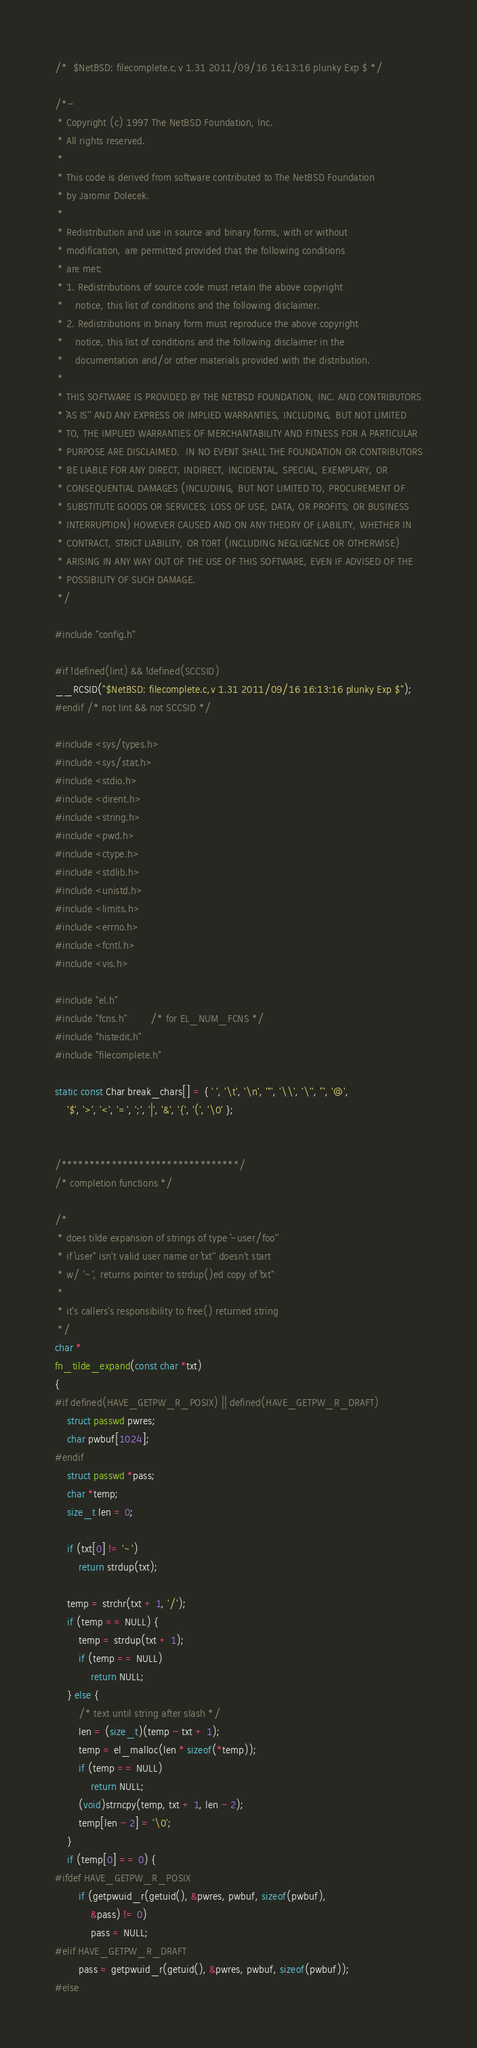<code> <loc_0><loc_0><loc_500><loc_500><_C_>/*	$NetBSD: filecomplete.c,v 1.31 2011/09/16 16:13:16 plunky Exp $	*/

/*-
 * Copyright (c) 1997 The NetBSD Foundation, Inc.
 * All rights reserved.
 *
 * This code is derived from software contributed to The NetBSD Foundation
 * by Jaromir Dolecek.
 *
 * Redistribution and use in source and binary forms, with or without
 * modification, are permitted provided that the following conditions
 * are met:
 * 1. Redistributions of source code must retain the above copyright
 *    notice, this list of conditions and the following disclaimer.
 * 2. Redistributions in binary form must reproduce the above copyright
 *    notice, this list of conditions and the following disclaimer in the
 *    documentation and/or other materials provided with the distribution.
 *
 * THIS SOFTWARE IS PROVIDED BY THE NETBSD FOUNDATION, INC. AND CONTRIBUTORS
 * ``AS IS'' AND ANY EXPRESS OR IMPLIED WARRANTIES, INCLUDING, BUT NOT LIMITED
 * TO, THE IMPLIED WARRANTIES OF MERCHANTABILITY AND FITNESS FOR A PARTICULAR
 * PURPOSE ARE DISCLAIMED.  IN NO EVENT SHALL THE FOUNDATION OR CONTRIBUTORS
 * BE LIABLE FOR ANY DIRECT, INDIRECT, INCIDENTAL, SPECIAL, EXEMPLARY, OR
 * CONSEQUENTIAL DAMAGES (INCLUDING, BUT NOT LIMITED TO, PROCUREMENT OF
 * SUBSTITUTE GOODS OR SERVICES; LOSS OF USE, DATA, OR PROFITS; OR BUSINESS
 * INTERRUPTION) HOWEVER CAUSED AND ON ANY THEORY OF LIABILITY, WHETHER IN
 * CONTRACT, STRICT LIABILITY, OR TORT (INCLUDING NEGLIGENCE OR OTHERWISE)
 * ARISING IN ANY WAY OUT OF THE USE OF THIS SOFTWARE, EVEN IF ADVISED OF THE
 * POSSIBILITY OF SUCH DAMAGE.
 */

#include "config.h"

#if !defined(lint) && !defined(SCCSID)
__RCSID("$NetBSD: filecomplete.c,v 1.31 2011/09/16 16:13:16 plunky Exp $");
#endif /* not lint && not SCCSID */

#include <sys/types.h>
#include <sys/stat.h>
#include <stdio.h>
#include <dirent.h>
#include <string.h>
#include <pwd.h>
#include <ctype.h>
#include <stdlib.h>
#include <unistd.h>
#include <limits.h>
#include <errno.h>
#include <fcntl.h>
#include <vis.h>

#include "el.h"
#include "fcns.h"		/* for EL_NUM_FCNS */
#include "histedit.h"
#include "filecomplete.h"

static const Char break_chars[] = { ' ', '\t', '\n', '"', '\\', '\'', '`', '@',
    '$', '>', '<', '=', ';', '|', '&', '{', '(', '\0' };


/********************************/
/* completion functions */

/*
 * does tilde expansion of strings of type ``~user/foo''
 * if ``user'' isn't valid user name or ``txt'' doesn't start
 * w/ '~', returns pointer to strdup()ed copy of ``txt''
 *
 * it's callers's responsibility to free() returned string
 */
char *
fn_tilde_expand(const char *txt)
{
#if defined(HAVE_GETPW_R_POSIX) || defined(HAVE_GETPW_R_DRAFT)
	struct passwd pwres;
	char pwbuf[1024];
#endif
	struct passwd *pass;
	char *temp;
	size_t len = 0;

	if (txt[0] != '~')
		return strdup(txt);

	temp = strchr(txt + 1, '/');
	if (temp == NULL) {
		temp = strdup(txt + 1);
		if (temp == NULL)
			return NULL;
	} else {
		/* text until string after slash */
		len = (size_t)(temp - txt + 1);
		temp = el_malloc(len * sizeof(*temp));
		if (temp == NULL)
			return NULL;
		(void)strncpy(temp, txt + 1, len - 2);
		temp[len - 2] = '\0';
	}
	if (temp[0] == 0) {
#ifdef HAVE_GETPW_R_POSIX
 		if (getpwuid_r(getuid(), &pwres, pwbuf, sizeof(pwbuf),
		    &pass) != 0)
 			pass = NULL;
#elif HAVE_GETPW_R_DRAFT
		pass = getpwuid_r(getuid(), &pwres, pwbuf, sizeof(pwbuf));
#else</code> 